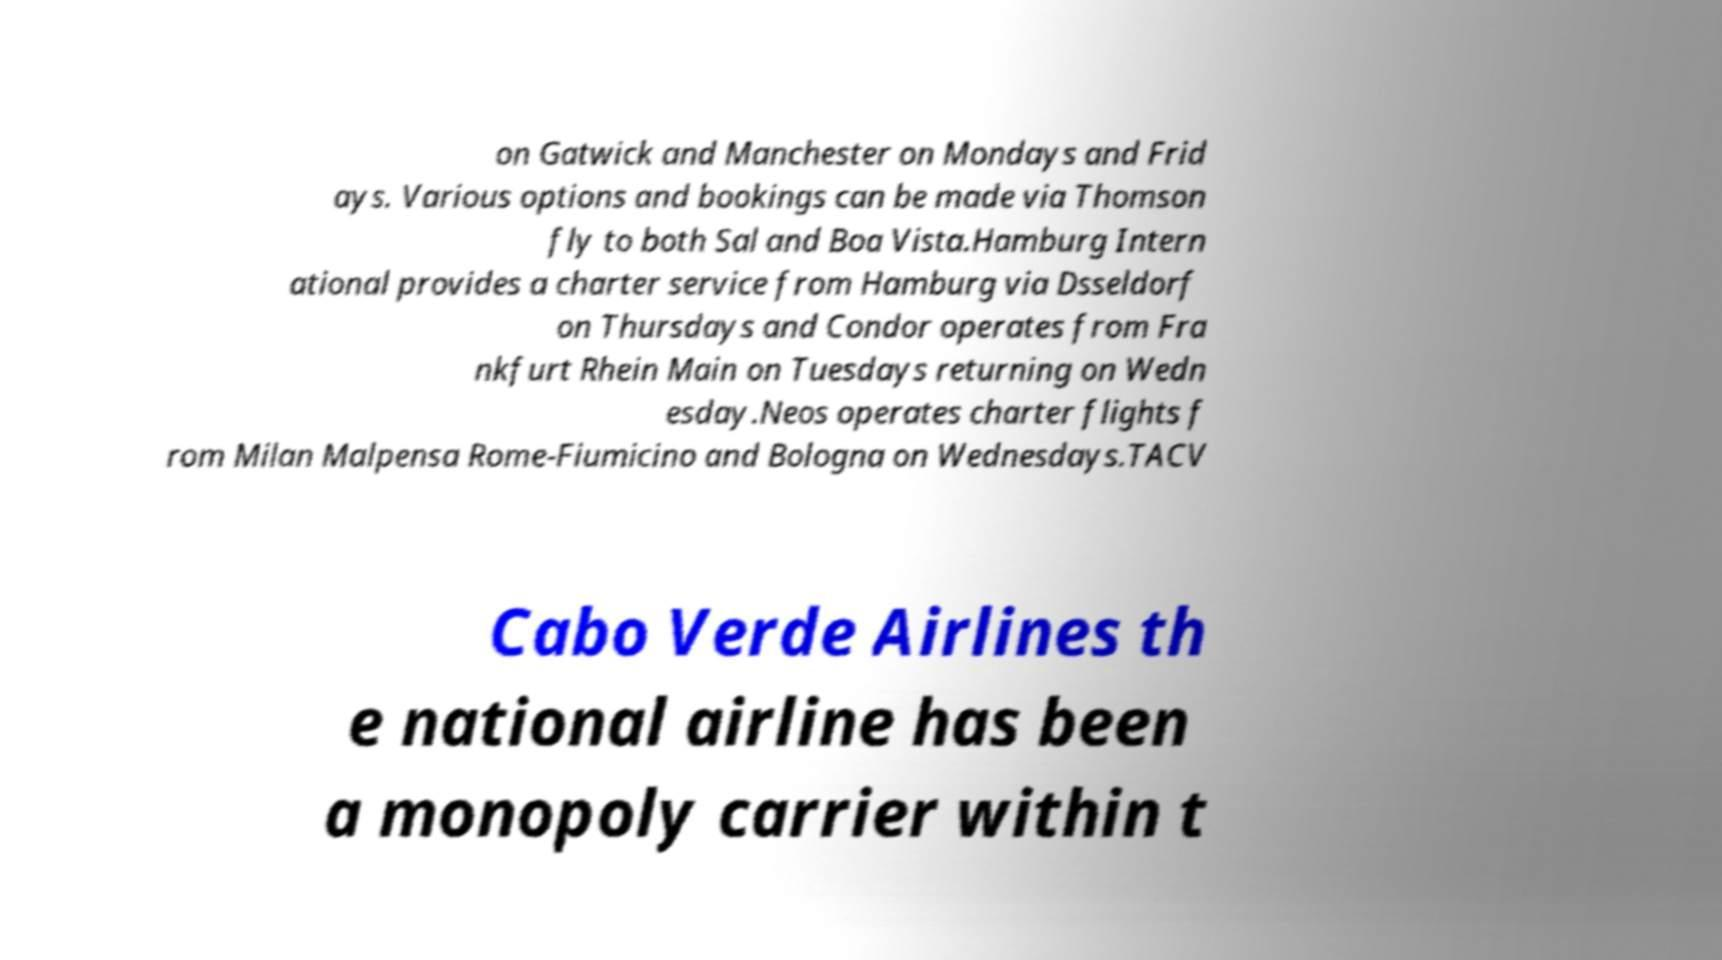Could you assist in decoding the text presented in this image and type it out clearly? on Gatwick and Manchester on Mondays and Frid ays. Various options and bookings can be made via Thomson fly to both Sal and Boa Vista.Hamburg Intern ational provides a charter service from Hamburg via Dsseldorf on Thursdays and Condor operates from Fra nkfurt Rhein Main on Tuesdays returning on Wedn esday.Neos operates charter flights f rom Milan Malpensa Rome-Fiumicino and Bologna on Wednesdays.TACV Cabo Verde Airlines th e national airline has been a monopoly carrier within t 